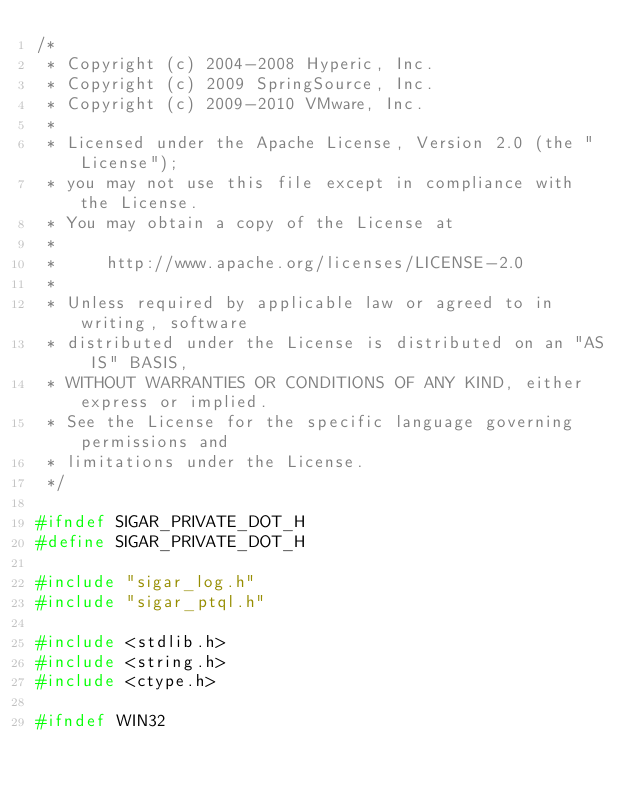<code> <loc_0><loc_0><loc_500><loc_500><_C_>/*
 * Copyright (c) 2004-2008 Hyperic, Inc.
 * Copyright (c) 2009 SpringSource, Inc.
 * Copyright (c) 2009-2010 VMware, Inc.
 *
 * Licensed under the Apache License, Version 2.0 (the "License");
 * you may not use this file except in compliance with the License.
 * You may obtain a copy of the License at
 *
 *     http://www.apache.org/licenses/LICENSE-2.0
 *
 * Unless required by applicable law or agreed to in writing, software
 * distributed under the License is distributed on an "AS IS" BASIS,
 * WITHOUT WARRANTIES OR CONDITIONS OF ANY KIND, either express or implied.
 * See the License for the specific language governing permissions and
 * limitations under the License.
 */

#ifndef SIGAR_PRIVATE_DOT_H
#define SIGAR_PRIVATE_DOT_H

#include "sigar_log.h"
#include "sigar_ptql.h"

#include <stdlib.h>
#include <string.h>
#include <ctype.h>

#ifndef WIN32</code> 